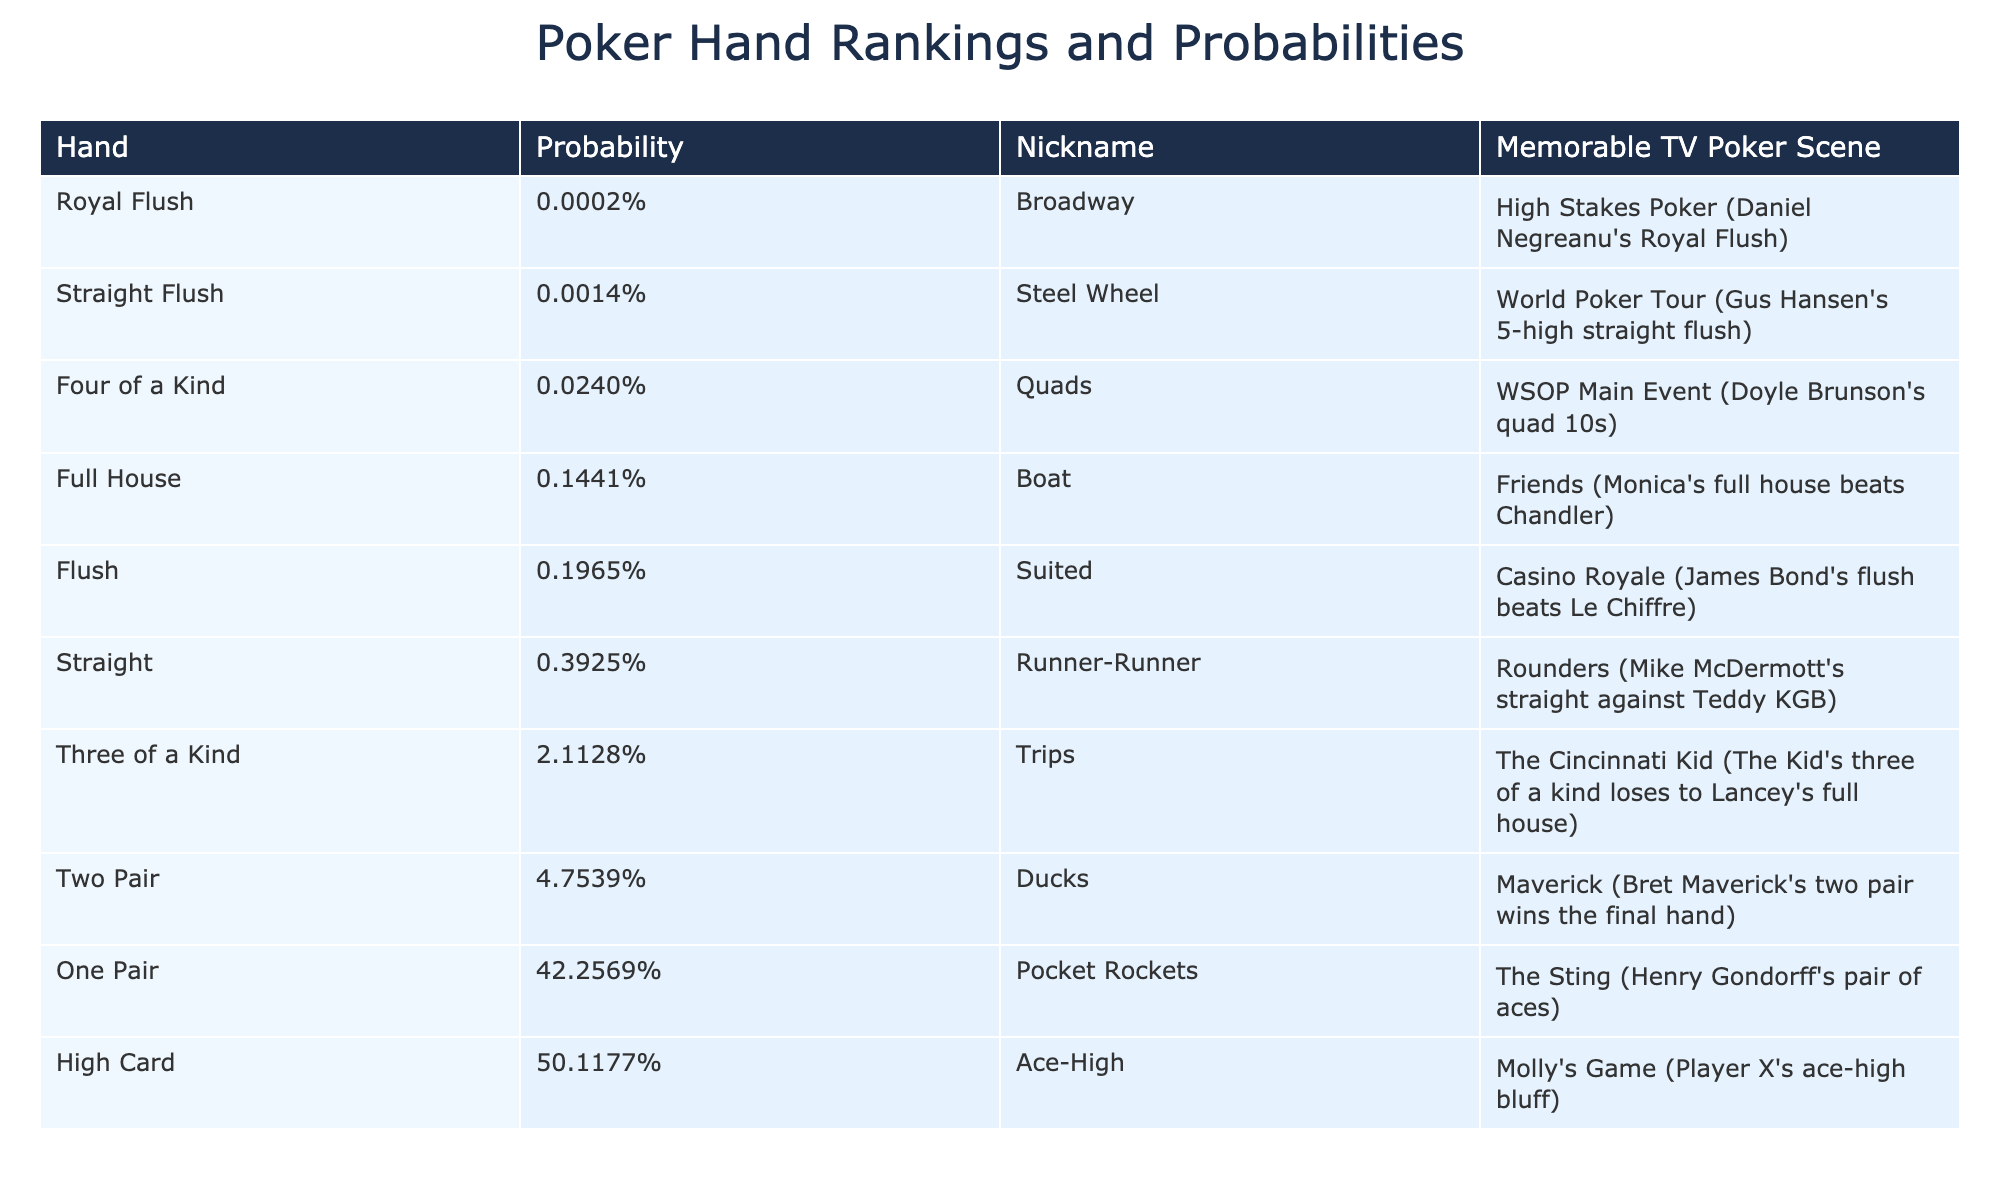What's the probability of getting a Royal Flush? The table lists the probability of a Royal Flush as 0.000154%.
Answer: 0.000154% Which hand has the highest probability? Looking at the table, the hand with the highest probability is "High Card" with 50.1177%.
Answer: High Card What is the difference in probability between a Flush and a Full House? The probability of a Flush is 0.1965%, while a Full House is 0.1441%. The difference is 0.1965% - 0.1441% = 0.0524%.
Answer: 0.0524% True or False: "One Pair" is more probable than "Two Pair." The probability of One Pair is 42.2569%, and the probability of Two Pair is 4.7539%. Since 42.2569% > 4.7539%, the statement is true.
Answer: True What is the combined probability of getting either a Straight Flush or Four of a Kind? The probability of a Straight Flush is 0.00139% and Four of a Kind is 0.0240%. Adding these together gives 0.00139% + 0.0240% = 0.02539%.
Answer: 0.02539% Which hand is more common, "Three of a Kind" or "Flush"? Comparing the probabilities, Three of a Kind has 2.1128% and Flush has 0.1965%. Since 2.1128% > 0.1965%, "Three of a Kind" is more common.
Answer: Three of a Kind If you draw one card, what's the likelihood of it being part of a Straight? The probability of a Straight is 0.3925%. Therefore, the likelihood of drawing one card that contributes to a Straight is this same percentage.
Answer: 0.3925% What is the total probability of getting any type of pair (One Pair, Two Pair, Three of a Kind, Four of a Kind)? Adding these probabilities: One Pair (42.2569%) + Two Pair (4.7539%) + Three of a Kind (2.1128%) + Four of a Kind (0.0240%) totals to 49.1476%.
Answer: 49.1476% Which poker hand ranked second in terms of probability? The second highest probability is for "One Pair," which has a probability of 42.2569%.
Answer: One Pair How often can you expect to get a High Card compared to a Royal Flush? The probability of a High Card is 50.1177%, while Royal Flush is 0.000154%. The expectation is significantly higher for a High Card.
Answer: High Card is much more likely 